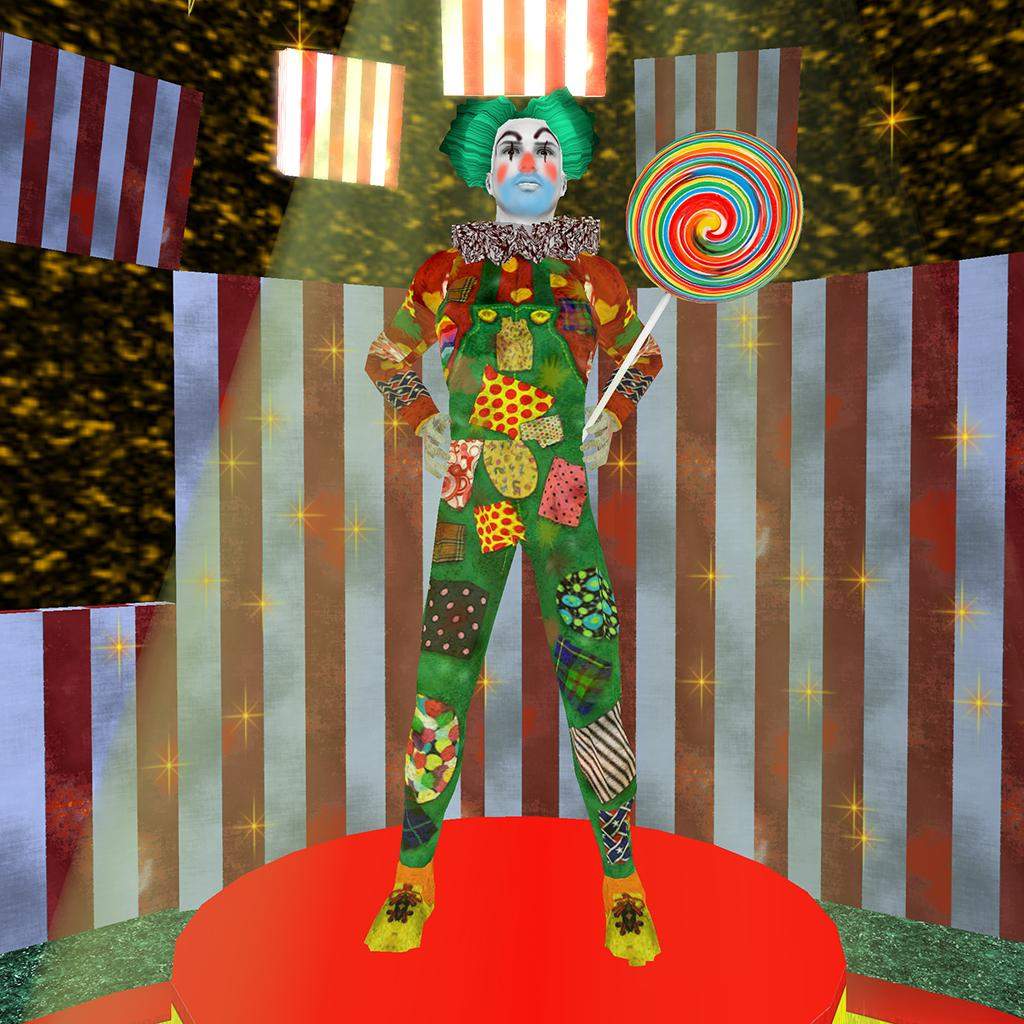What is the main subject of the image? There is a person standing in the image. What can be observed about the person's attire? The person is wearing clothes. What object is the person holding in their hand? The person is holding a lollipop in their hand. What can be seen in the background of the image? There is a wall in the background of the image. What is notable about the wall's appearance? The wall has decorative elements. What type of drum can be heard playing in the background of the image? There is no drum or sound present in the image; it is a still image of a person holding a lollipop. 